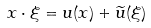<formula> <loc_0><loc_0><loc_500><loc_500>x \cdot \xi = u ( x ) + \widetilde { u } ( \xi )</formula> 